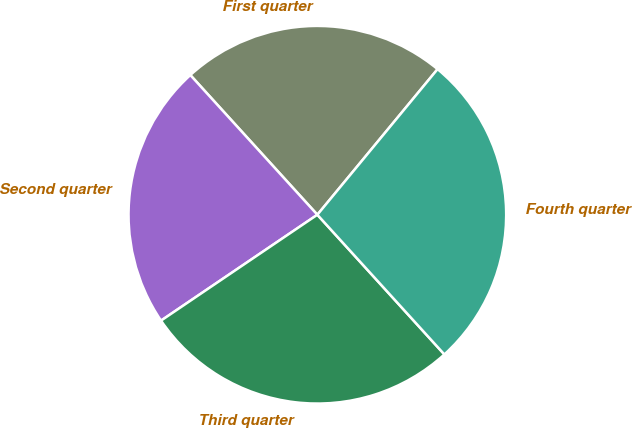Convert chart to OTSL. <chart><loc_0><loc_0><loc_500><loc_500><pie_chart><fcel>First quarter<fcel>Second quarter<fcel>Third quarter<fcel>Fourth quarter<nl><fcel>22.73%<fcel>22.73%<fcel>27.27%<fcel>27.27%<nl></chart> 